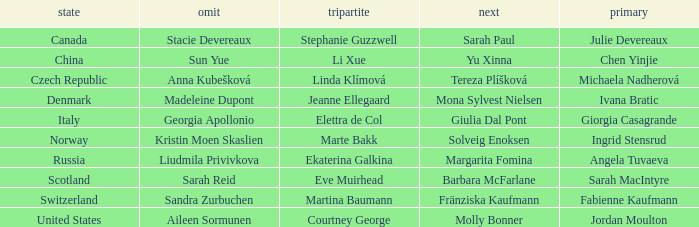What skip has switzerland as the country? Sandra Zurbuchen. 